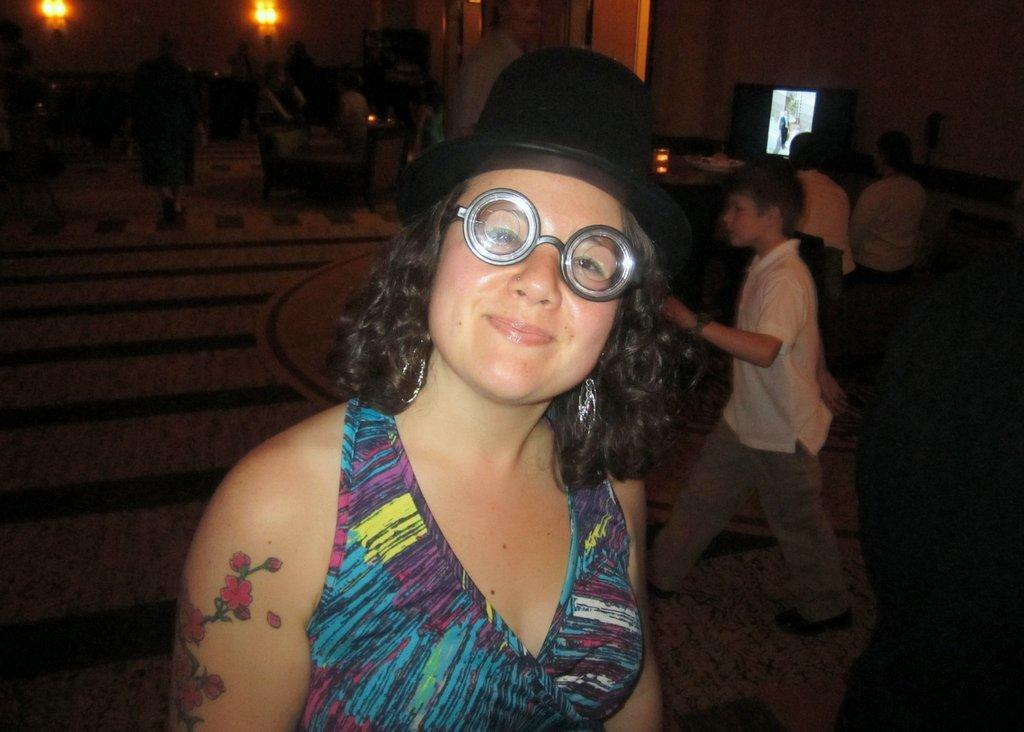How many people are in the image? There are persons in the image. What is located at the top of the image? There is a screen at the top of the image. Can you describe the woman in the image? The woman in the image is wearing a hat and goggles. What type of cart is being pulled by the horse in the image? There is no horse or cart present in the image. What material is the cloth used for the woman's hat made of? The woman in the image is wearing a hat, but there is no information provided about the material it is made of. 